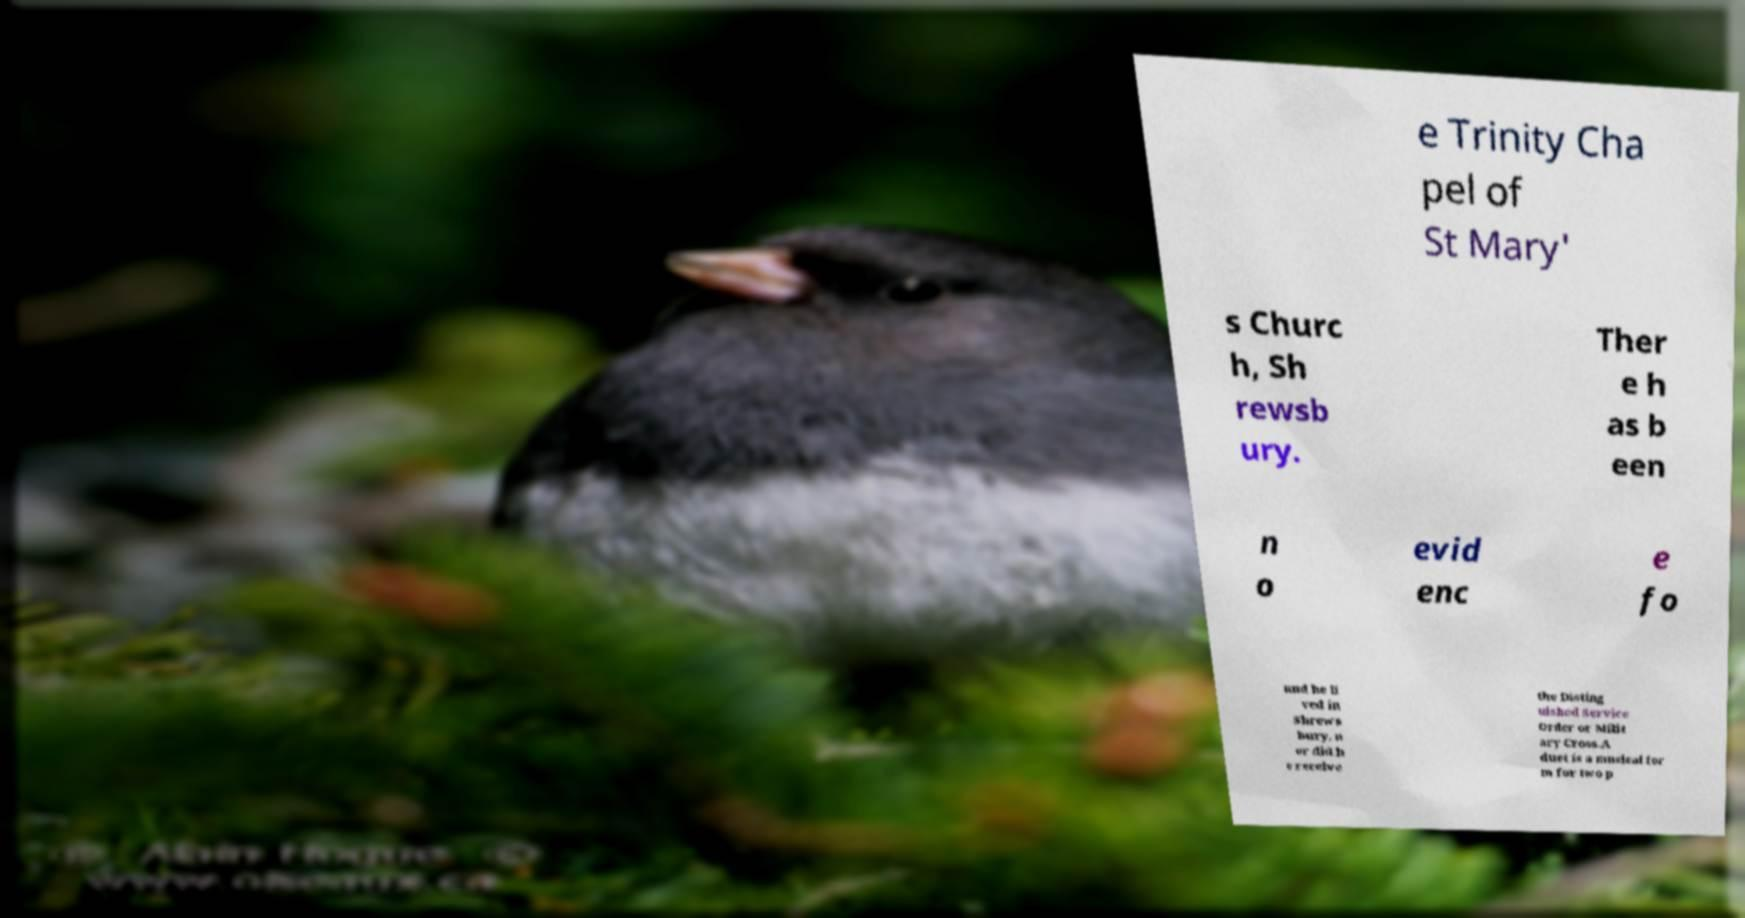Please identify and transcribe the text found in this image. e Trinity Cha pel of St Mary' s Churc h, Sh rewsb ury. Ther e h as b een n o evid enc e fo und he li ved in Shrews bury, n or did h e receive the Disting uished Service Order or Milit ary Cross.A duet is a musical for m for two p 